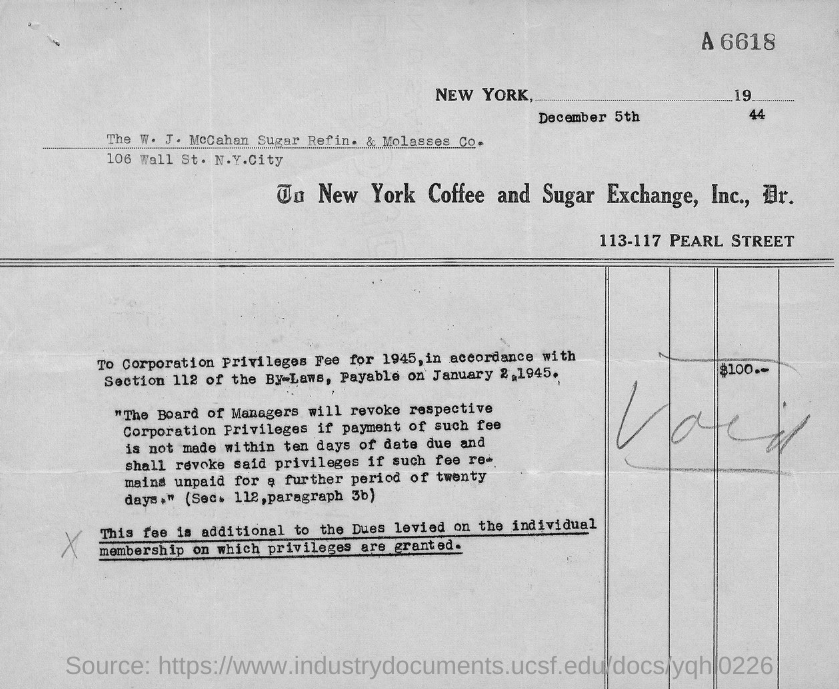What is the total fee?
Provide a succinct answer. $100. 